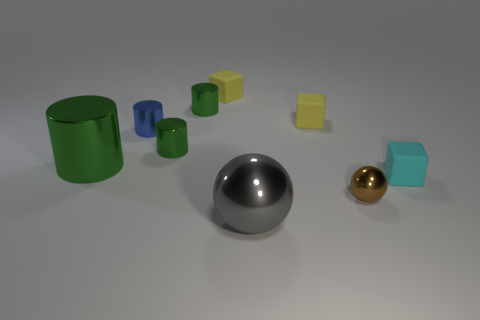How many tiny green metal objects have the same shape as the tiny blue thing?
Your answer should be very brief. 2. What number of yellow blocks are the same size as the brown metal thing?
Your response must be concise. 2. What is the material of the other thing that is the same shape as the brown metallic thing?
Provide a short and direct response. Metal. What is the color of the tiny rubber thing that is in front of the small blue metal object?
Your answer should be very brief. Cyan. Are there more blue shiny cylinders that are to the left of the blue cylinder than large yellow rubber balls?
Your answer should be compact. No. What color is the big metallic sphere?
Provide a short and direct response. Gray. What shape is the gray metal object on the right side of the yellow object left of the ball left of the brown shiny ball?
Provide a succinct answer. Sphere. What material is the block that is both on the right side of the big sphere and behind the blue metallic cylinder?
Your answer should be very brief. Rubber. There is a large object in front of the rubber thing right of the small brown ball; what is its shape?
Provide a succinct answer. Sphere. Are there any other things of the same color as the big metal cylinder?
Offer a terse response. Yes. 